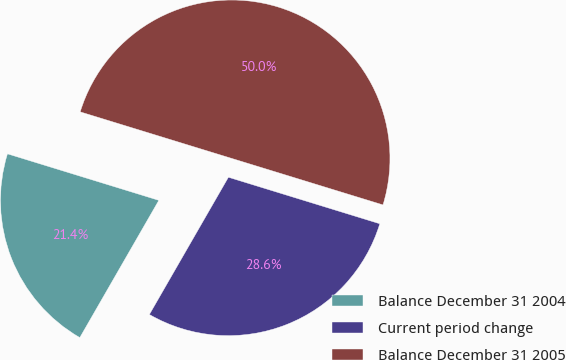Convert chart. <chart><loc_0><loc_0><loc_500><loc_500><pie_chart><fcel>Balance December 31 2004<fcel>Current period change<fcel>Balance December 31 2005<nl><fcel>21.43%<fcel>28.57%<fcel>50.0%<nl></chart> 